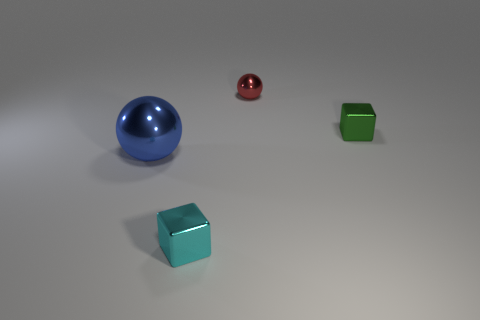There is a small object that is the same shape as the large blue shiny thing; what is its color?
Your response must be concise. Red. There is a tiny shiny object that is behind the green object; is its shape the same as the large blue shiny object that is on the left side of the small red thing?
Keep it short and to the point. Yes. How many tiny green things are in front of the tiny cyan metal cube?
Ensure brevity in your answer.  0. What number of other small green blocks are the same material as the green block?
Ensure brevity in your answer.  0. What color is the block that is made of the same material as the green object?
Your answer should be very brief. Cyan. The tiny block that is to the right of the shiny cube that is in front of the small thing that is on the right side of the small metallic sphere is made of what material?
Provide a succinct answer. Metal. There is a thing that is in front of the blue metallic thing; is its size the same as the big blue shiny thing?
Offer a terse response. No. How many big objects are red balls or green cylinders?
Ensure brevity in your answer.  0. Is there a block of the same color as the large object?
Provide a short and direct response. No. What is the shape of the green object that is the same size as the cyan block?
Your answer should be compact. Cube. 